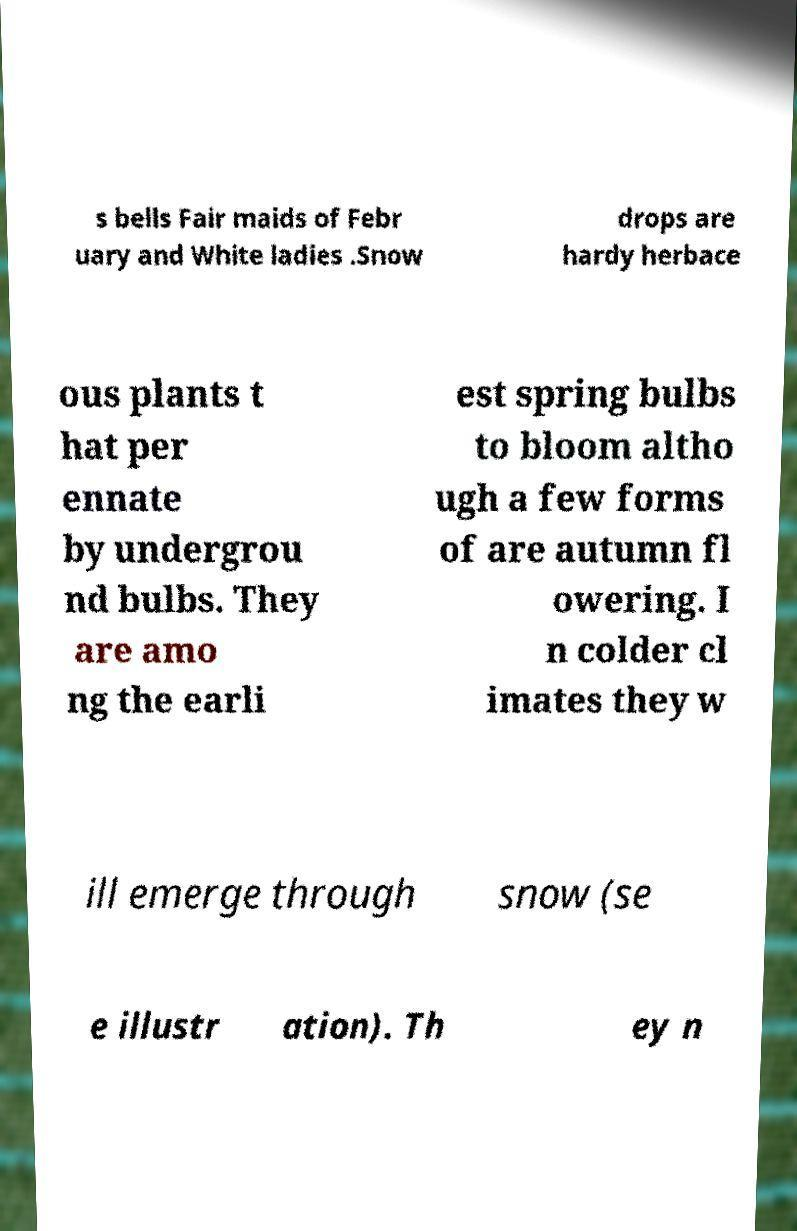What messages or text are displayed in this image? I need them in a readable, typed format. s bells Fair maids of Febr uary and White ladies .Snow drops are hardy herbace ous plants t hat per ennate by undergrou nd bulbs. They are amo ng the earli est spring bulbs to bloom altho ugh a few forms of are autumn fl owering. I n colder cl imates they w ill emerge through snow (se e illustr ation). Th ey n 